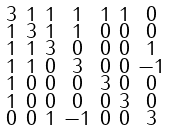<formula> <loc_0><loc_0><loc_500><loc_500>\begin{smallmatrix} 3 & 1 & 1 & 1 & 1 & 1 & 0 \\ 1 & 3 & 1 & 1 & 0 & 0 & 0 \\ 1 & 1 & 3 & 0 & 0 & 0 & 1 \\ 1 & 1 & 0 & 3 & 0 & 0 & - 1 \\ 1 & 0 & 0 & 0 & 3 & 0 & 0 \\ 1 & 0 & 0 & 0 & 0 & 3 & 0 \\ 0 & 0 & 1 & - 1 & 0 & 0 & 3 \end{smallmatrix}</formula> 